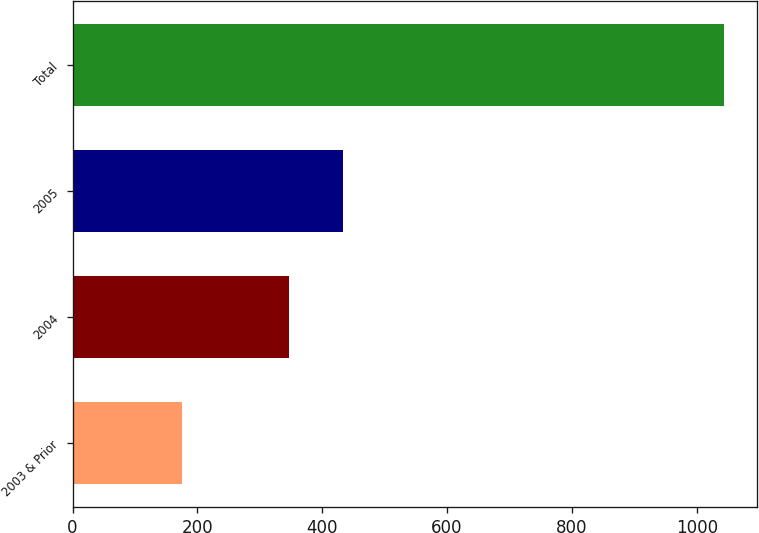Convert chart to OTSL. <chart><loc_0><loc_0><loc_500><loc_500><bar_chart><fcel>2003 & Prior<fcel>2004<fcel>2005<fcel>Total<nl><fcel>176<fcel>347<fcel>433.8<fcel>1044<nl></chart> 